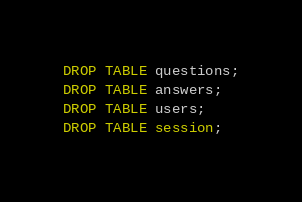<code> <loc_0><loc_0><loc_500><loc_500><_SQL_>DROP TABLE questions;
DROP TABLE answers;
DROP TABLE users;
DROP TABLE session;
</code> 